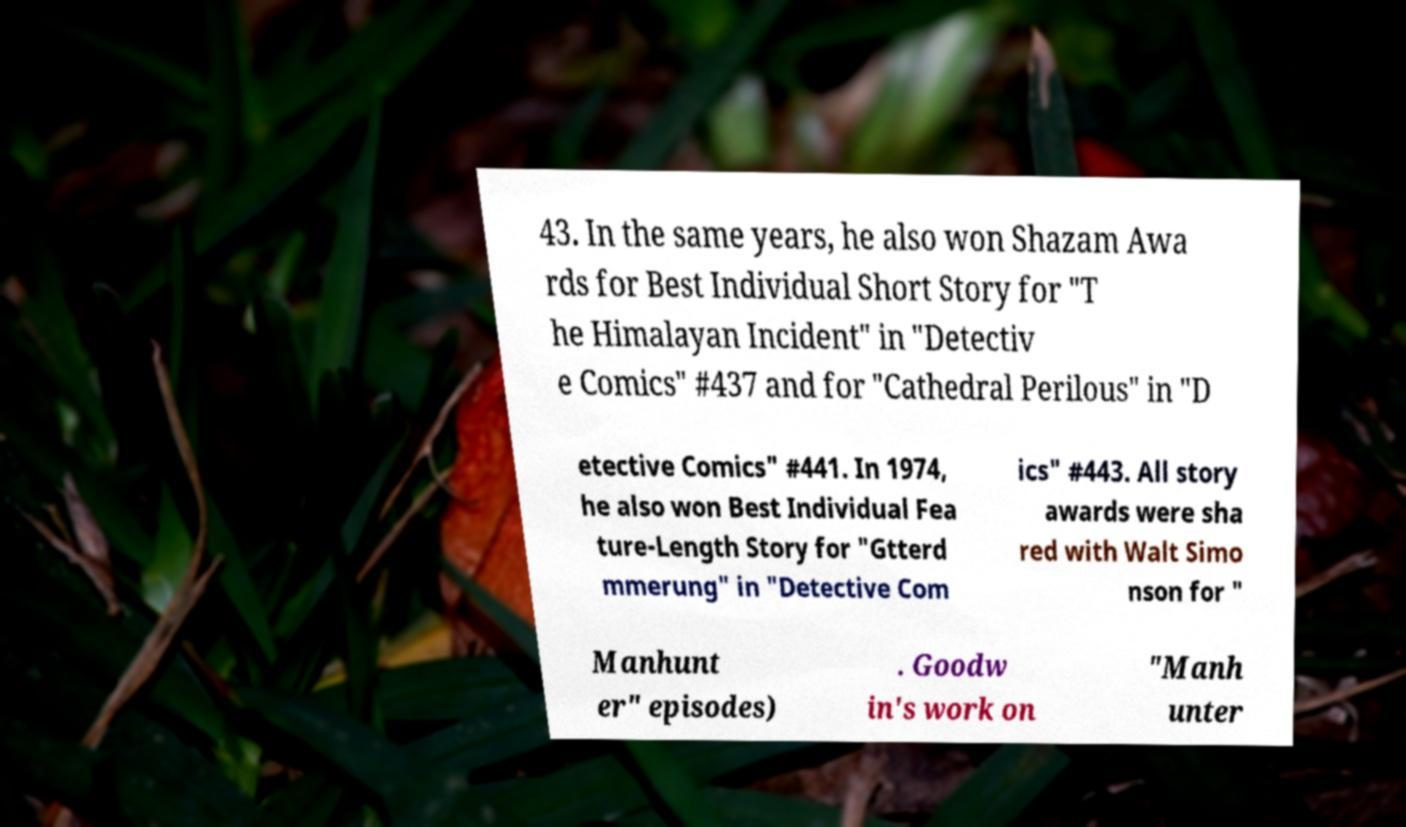I need the written content from this picture converted into text. Can you do that? 43. In the same years, he also won Shazam Awa rds for Best Individual Short Story for "T he Himalayan Incident" in "Detectiv e Comics" #437 and for "Cathedral Perilous" in "D etective Comics" #441. In 1974, he also won Best Individual Fea ture-Length Story for "Gtterd mmerung" in "Detective Com ics" #443. All story awards were sha red with Walt Simo nson for " Manhunt er" episodes) . Goodw in's work on "Manh unter 